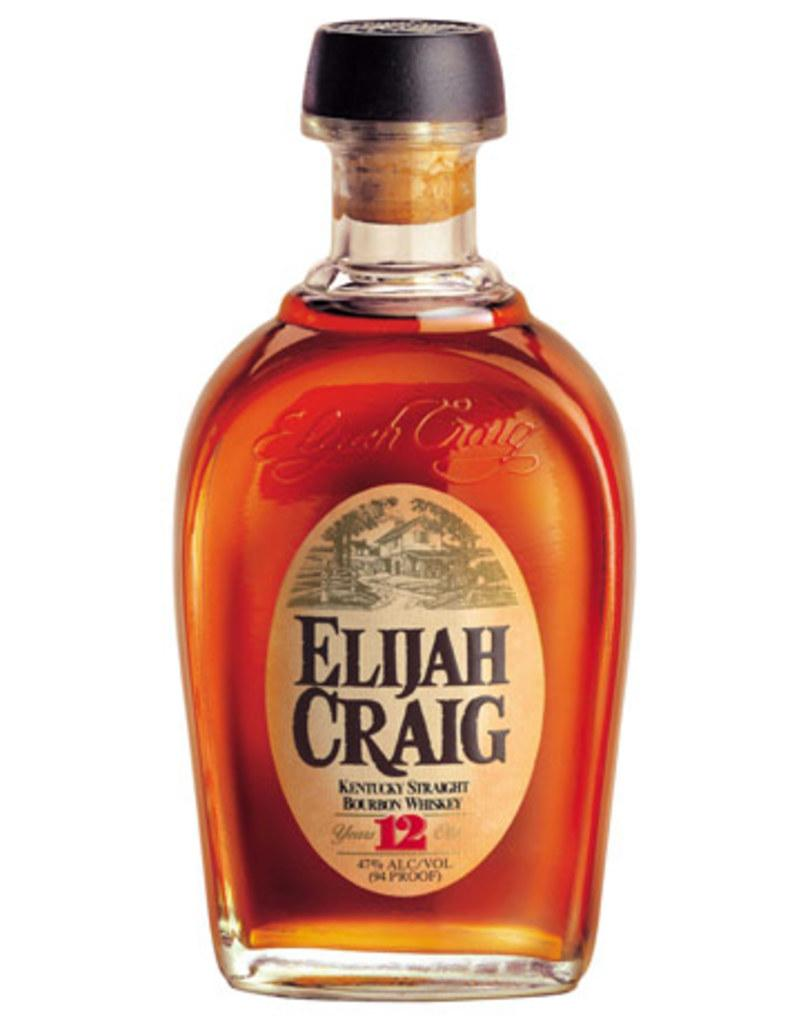<image>
Write a terse but informative summary of the picture. A bottle of Elijah Craig Kentucky Straight Bourbon Whiskey. 